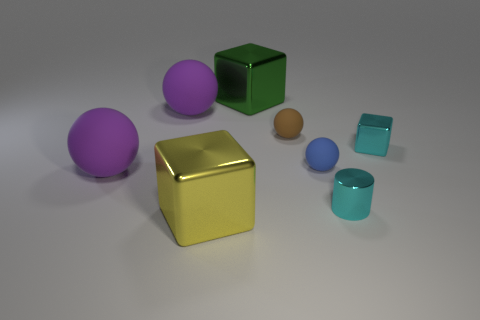What number of other blocks have the same material as the small cube?
Your answer should be compact. 2. What number of rubber objects are tiny blue things or tiny brown things?
Keep it short and to the point. 2. Do the blue matte thing that is on the right side of the green metallic block and the purple thing in front of the tiny blue rubber ball have the same shape?
Offer a terse response. Yes. What color is the shiny cube that is both behind the yellow metal object and left of the cyan cube?
Provide a succinct answer. Green. Is the size of the shiny block left of the big green shiny block the same as the green cube that is on the left side of the tiny cyan cylinder?
Your response must be concise. Yes. How many other cylinders are the same color as the tiny cylinder?
Provide a short and direct response. 0. What number of big objects are brown matte spheres or cyan matte balls?
Your answer should be compact. 0. Are the cyan cylinder that is behind the large yellow shiny thing and the green object made of the same material?
Your response must be concise. Yes. There is a big cube that is behind the big yellow metal cube; what color is it?
Make the answer very short. Green. Is there a cube that has the same size as the green object?
Make the answer very short. Yes. 